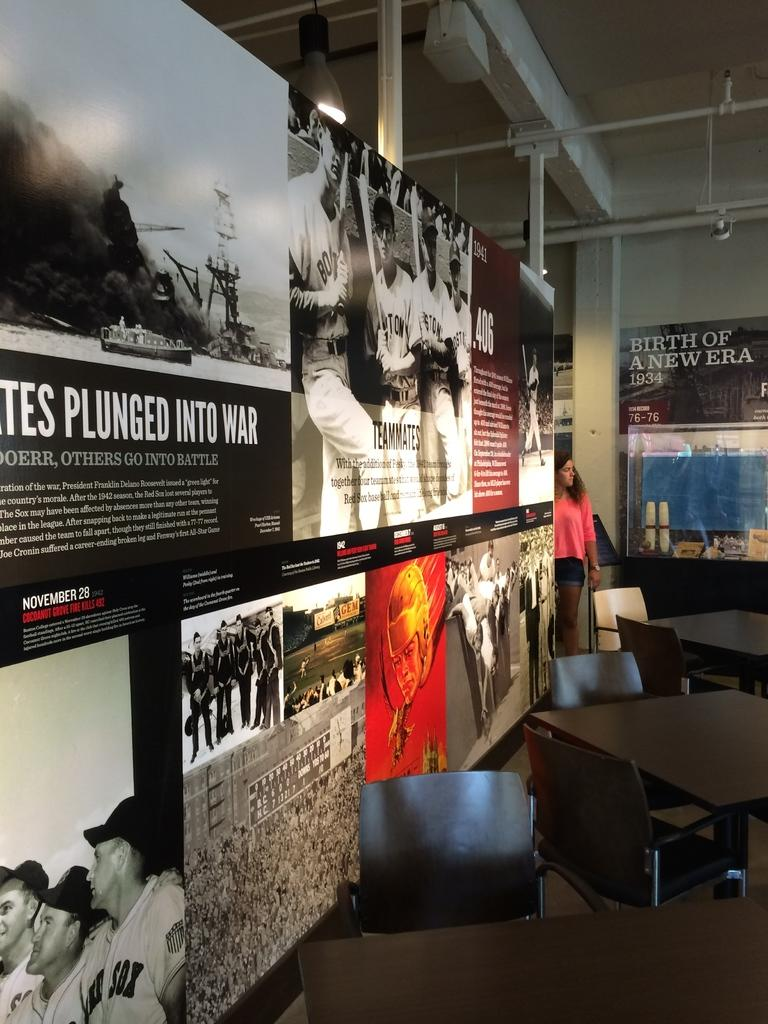What is located on the left side of the image? There is a hoarding on the left side of the image. Who is near the hoarding? There is a woman near the hoarding. What furniture is visible beside the hoarding? There are tables and chairs beside the hoarding. What can be seen in the background of the image? There is a wall and poles in the background of the image, as well as another hoarding. What type of shoe is the woman wearing in the image? There is no information about the woman's shoes in the image, so we cannot determine the type of shoe she is wearing. What government policy is being advertised on the hoarding? There is no indication of any government policy being advertised on the hoarding; it may be promoting a product or service. 